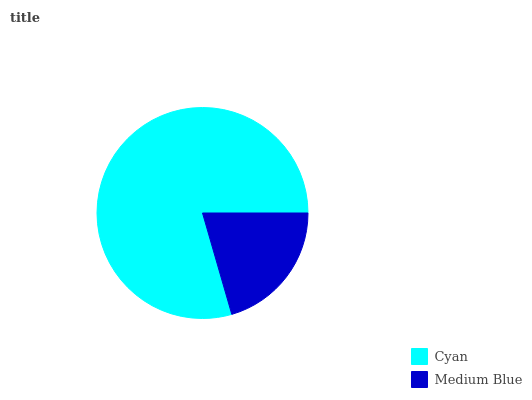Is Medium Blue the minimum?
Answer yes or no. Yes. Is Cyan the maximum?
Answer yes or no. Yes. Is Medium Blue the maximum?
Answer yes or no. No. Is Cyan greater than Medium Blue?
Answer yes or no. Yes. Is Medium Blue less than Cyan?
Answer yes or no. Yes. Is Medium Blue greater than Cyan?
Answer yes or no. No. Is Cyan less than Medium Blue?
Answer yes or no. No. Is Cyan the high median?
Answer yes or no. Yes. Is Medium Blue the low median?
Answer yes or no. Yes. Is Medium Blue the high median?
Answer yes or no. No. Is Cyan the low median?
Answer yes or no. No. 